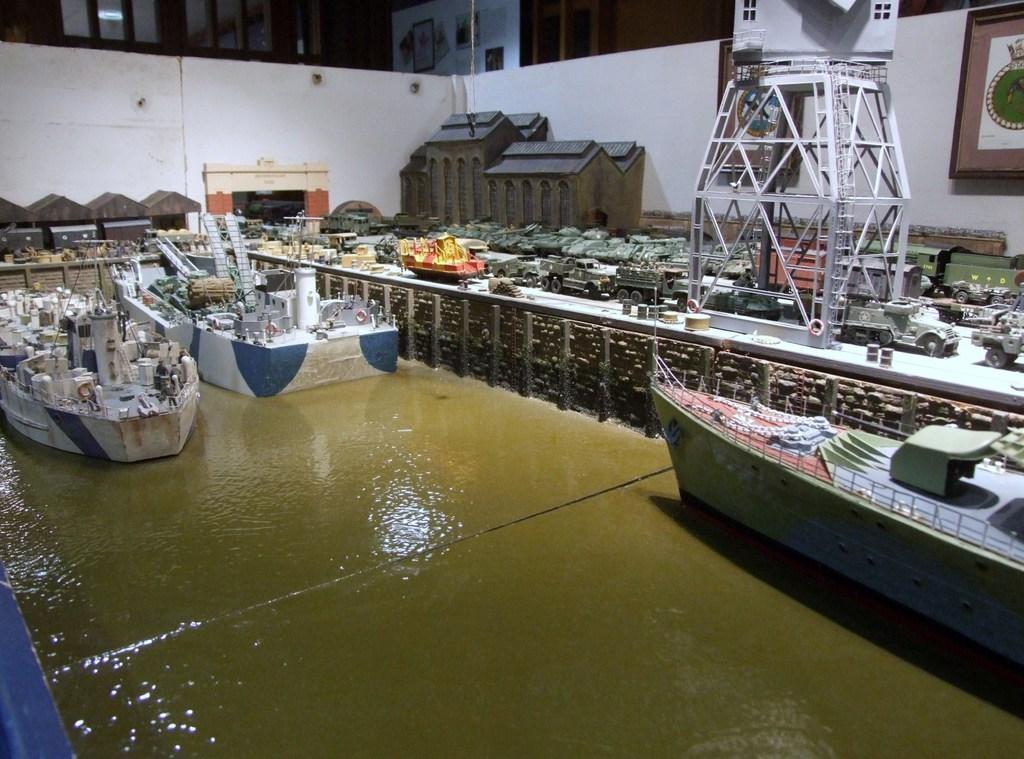Can you describe this image briefly? In this picture we can see a few boats. There is water on the path. We can see houses, white object and a few toys. There is a frame on the wall. We can see some frames on a wooden surface in the background. 